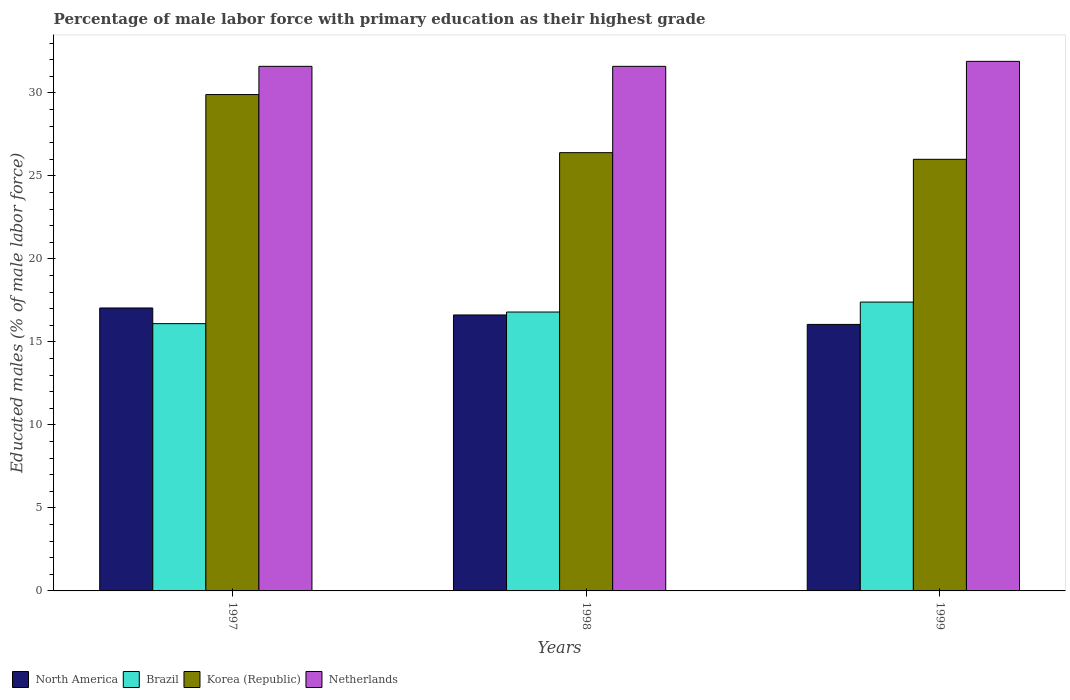How many different coloured bars are there?
Your answer should be compact. 4. How many groups of bars are there?
Provide a short and direct response. 3. Are the number of bars per tick equal to the number of legend labels?
Provide a short and direct response. Yes. What is the label of the 2nd group of bars from the left?
Give a very brief answer. 1998. What is the percentage of male labor force with primary education in Korea (Republic) in 1997?
Provide a short and direct response. 29.9. Across all years, what is the maximum percentage of male labor force with primary education in North America?
Keep it short and to the point. 17.04. Across all years, what is the minimum percentage of male labor force with primary education in North America?
Your response must be concise. 16.05. In which year was the percentage of male labor force with primary education in Netherlands minimum?
Ensure brevity in your answer.  1997. What is the total percentage of male labor force with primary education in Brazil in the graph?
Your response must be concise. 50.3. What is the difference between the percentage of male labor force with primary education in Korea (Republic) in 1998 and that in 1999?
Offer a very short reply. 0.4. What is the difference between the percentage of male labor force with primary education in North America in 1998 and the percentage of male labor force with primary education in Netherlands in 1999?
Your answer should be compact. -15.28. What is the average percentage of male labor force with primary education in Korea (Republic) per year?
Your response must be concise. 27.43. In the year 1997, what is the difference between the percentage of male labor force with primary education in Brazil and percentage of male labor force with primary education in Korea (Republic)?
Give a very brief answer. -13.8. In how many years, is the percentage of male labor force with primary education in Korea (Republic) greater than 21 %?
Your response must be concise. 3. What is the ratio of the percentage of male labor force with primary education in Brazil in 1997 to that in 1999?
Provide a short and direct response. 0.93. Is the percentage of male labor force with primary education in Brazil in 1997 less than that in 1998?
Offer a very short reply. Yes. Is the difference between the percentage of male labor force with primary education in Brazil in 1998 and 1999 greater than the difference between the percentage of male labor force with primary education in Korea (Republic) in 1998 and 1999?
Your answer should be very brief. No. What is the difference between the highest and the second highest percentage of male labor force with primary education in North America?
Your answer should be very brief. 0.42. What is the difference between the highest and the lowest percentage of male labor force with primary education in Brazil?
Offer a terse response. 1.3. In how many years, is the percentage of male labor force with primary education in North America greater than the average percentage of male labor force with primary education in North America taken over all years?
Give a very brief answer. 2. Is the sum of the percentage of male labor force with primary education in Korea (Republic) in 1998 and 1999 greater than the maximum percentage of male labor force with primary education in Netherlands across all years?
Ensure brevity in your answer.  Yes. What does the 2nd bar from the left in 1999 represents?
Your response must be concise. Brazil. What does the 1st bar from the right in 1997 represents?
Make the answer very short. Netherlands. Is it the case that in every year, the sum of the percentage of male labor force with primary education in Brazil and percentage of male labor force with primary education in North America is greater than the percentage of male labor force with primary education in Korea (Republic)?
Offer a terse response. Yes. What is the difference between two consecutive major ticks on the Y-axis?
Keep it short and to the point. 5. Does the graph contain grids?
Offer a terse response. No. How many legend labels are there?
Offer a very short reply. 4. How are the legend labels stacked?
Your answer should be compact. Horizontal. What is the title of the graph?
Your response must be concise. Percentage of male labor force with primary education as their highest grade. What is the label or title of the Y-axis?
Your response must be concise. Educated males (% of male labor force). What is the Educated males (% of male labor force) of North America in 1997?
Provide a short and direct response. 17.04. What is the Educated males (% of male labor force) of Brazil in 1997?
Your answer should be very brief. 16.1. What is the Educated males (% of male labor force) of Korea (Republic) in 1997?
Provide a short and direct response. 29.9. What is the Educated males (% of male labor force) in Netherlands in 1997?
Provide a succinct answer. 31.6. What is the Educated males (% of male labor force) in North America in 1998?
Ensure brevity in your answer.  16.62. What is the Educated males (% of male labor force) of Brazil in 1998?
Your answer should be compact. 16.8. What is the Educated males (% of male labor force) in Korea (Republic) in 1998?
Make the answer very short. 26.4. What is the Educated males (% of male labor force) of Netherlands in 1998?
Your answer should be very brief. 31.6. What is the Educated males (% of male labor force) in North America in 1999?
Offer a terse response. 16.05. What is the Educated males (% of male labor force) of Brazil in 1999?
Your answer should be compact. 17.4. What is the Educated males (% of male labor force) of Netherlands in 1999?
Your answer should be compact. 31.9. Across all years, what is the maximum Educated males (% of male labor force) in North America?
Give a very brief answer. 17.04. Across all years, what is the maximum Educated males (% of male labor force) in Brazil?
Keep it short and to the point. 17.4. Across all years, what is the maximum Educated males (% of male labor force) in Korea (Republic)?
Provide a succinct answer. 29.9. Across all years, what is the maximum Educated males (% of male labor force) in Netherlands?
Your answer should be very brief. 31.9. Across all years, what is the minimum Educated males (% of male labor force) of North America?
Give a very brief answer. 16.05. Across all years, what is the minimum Educated males (% of male labor force) in Brazil?
Keep it short and to the point. 16.1. Across all years, what is the minimum Educated males (% of male labor force) in Netherlands?
Give a very brief answer. 31.6. What is the total Educated males (% of male labor force) in North America in the graph?
Your response must be concise. 49.72. What is the total Educated males (% of male labor force) in Brazil in the graph?
Provide a succinct answer. 50.3. What is the total Educated males (% of male labor force) in Korea (Republic) in the graph?
Ensure brevity in your answer.  82.3. What is the total Educated males (% of male labor force) in Netherlands in the graph?
Your response must be concise. 95.1. What is the difference between the Educated males (% of male labor force) in North America in 1997 and that in 1998?
Provide a succinct answer. 0.42. What is the difference between the Educated males (% of male labor force) in Korea (Republic) in 1997 and that in 1998?
Your response must be concise. 3.5. What is the difference between the Educated males (% of male labor force) in Netherlands in 1997 and that in 1998?
Provide a succinct answer. 0. What is the difference between the Educated males (% of male labor force) of North America in 1997 and that in 1999?
Offer a terse response. 0.99. What is the difference between the Educated males (% of male labor force) of Brazil in 1997 and that in 1999?
Provide a short and direct response. -1.3. What is the difference between the Educated males (% of male labor force) of North America in 1998 and that in 1999?
Provide a short and direct response. 0.57. What is the difference between the Educated males (% of male labor force) in Korea (Republic) in 1998 and that in 1999?
Your response must be concise. 0.4. What is the difference between the Educated males (% of male labor force) in North America in 1997 and the Educated males (% of male labor force) in Brazil in 1998?
Offer a terse response. 0.24. What is the difference between the Educated males (% of male labor force) of North America in 1997 and the Educated males (% of male labor force) of Korea (Republic) in 1998?
Your answer should be very brief. -9.36. What is the difference between the Educated males (% of male labor force) in North America in 1997 and the Educated males (% of male labor force) in Netherlands in 1998?
Your answer should be compact. -14.56. What is the difference between the Educated males (% of male labor force) of Brazil in 1997 and the Educated males (% of male labor force) of Netherlands in 1998?
Make the answer very short. -15.5. What is the difference between the Educated males (% of male labor force) in Korea (Republic) in 1997 and the Educated males (% of male labor force) in Netherlands in 1998?
Make the answer very short. -1.7. What is the difference between the Educated males (% of male labor force) of North America in 1997 and the Educated males (% of male labor force) of Brazil in 1999?
Your answer should be compact. -0.36. What is the difference between the Educated males (% of male labor force) of North America in 1997 and the Educated males (% of male labor force) of Korea (Republic) in 1999?
Your response must be concise. -8.96. What is the difference between the Educated males (% of male labor force) of North America in 1997 and the Educated males (% of male labor force) of Netherlands in 1999?
Your answer should be very brief. -14.86. What is the difference between the Educated males (% of male labor force) in Brazil in 1997 and the Educated males (% of male labor force) in Korea (Republic) in 1999?
Give a very brief answer. -9.9. What is the difference between the Educated males (% of male labor force) of Brazil in 1997 and the Educated males (% of male labor force) of Netherlands in 1999?
Make the answer very short. -15.8. What is the difference between the Educated males (% of male labor force) in Korea (Republic) in 1997 and the Educated males (% of male labor force) in Netherlands in 1999?
Provide a short and direct response. -2. What is the difference between the Educated males (% of male labor force) in North America in 1998 and the Educated males (% of male labor force) in Brazil in 1999?
Provide a succinct answer. -0.78. What is the difference between the Educated males (% of male labor force) in North America in 1998 and the Educated males (% of male labor force) in Korea (Republic) in 1999?
Offer a terse response. -9.38. What is the difference between the Educated males (% of male labor force) in North America in 1998 and the Educated males (% of male labor force) in Netherlands in 1999?
Provide a succinct answer. -15.28. What is the difference between the Educated males (% of male labor force) in Brazil in 1998 and the Educated males (% of male labor force) in Netherlands in 1999?
Your response must be concise. -15.1. What is the difference between the Educated males (% of male labor force) of Korea (Republic) in 1998 and the Educated males (% of male labor force) of Netherlands in 1999?
Offer a terse response. -5.5. What is the average Educated males (% of male labor force) in North America per year?
Your response must be concise. 16.57. What is the average Educated males (% of male labor force) in Brazil per year?
Offer a terse response. 16.77. What is the average Educated males (% of male labor force) in Korea (Republic) per year?
Ensure brevity in your answer.  27.43. What is the average Educated males (% of male labor force) of Netherlands per year?
Provide a short and direct response. 31.7. In the year 1997, what is the difference between the Educated males (% of male labor force) of North America and Educated males (% of male labor force) of Brazil?
Offer a very short reply. 0.94. In the year 1997, what is the difference between the Educated males (% of male labor force) in North America and Educated males (% of male labor force) in Korea (Republic)?
Provide a succinct answer. -12.86. In the year 1997, what is the difference between the Educated males (% of male labor force) in North America and Educated males (% of male labor force) in Netherlands?
Ensure brevity in your answer.  -14.56. In the year 1997, what is the difference between the Educated males (% of male labor force) of Brazil and Educated males (% of male labor force) of Korea (Republic)?
Your response must be concise. -13.8. In the year 1997, what is the difference between the Educated males (% of male labor force) in Brazil and Educated males (% of male labor force) in Netherlands?
Your answer should be very brief. -15.5. In the year 1998, what is the difference between the Educated males (% of male labor force) in North America and Educated males (% of male labor force) in Brazil?
Your answer should be very brief. -0.18. In the year 1998, what is the difference between the Educated males (% of male labor force) of North America and Educated males (% of male labor force) of Korea (Republic)?
Your answer should be very brief. -9.78. In the year 1998, what is the difference between the Educated males (% of male labor force) in North America and Educated males (% of male labor force) in Netherlands?
Give a very brief answer. -14.98. In the year 1998, what is the difference between the Educated males (% of male labor force) of Brazil and Educated males (% of male labor force) of Korea (Republic)?
Provide a short and direct response. -9.6. In the year 1998, what is the difference between the Educated males (% of male labor force) in Brazil and Educated males (% of male labor force) in Netherlands?
Your answer should be very brief. -14.8. In the year 1999, what is the difference between the Educated males (% of male labor force) in North America and Educated males (% of male labor force) in Brazil?
Provide a short and direct response. -1.35. In the year 1999, what is the difference between the Educated males (% of male labor force) in North America and Educated males (% of male labor force) in Korea (Republic)?
Your answer should be compact. -9.95. In the year 1999, what is the difference between the Educated males (% of male labor force) in North America and Educated males (% of male labor force) in Netherlands?
Your response must be concise. -15.85. In the year 1999, what is the difference between the Educated males (% of male labor force) of Brazil and Educated males (% of male labor force) of Netherlands?
Make the answer very short. -14.5. What is the ratio of the Educated males (% of male labor force) in North America in 1997 to that in 1998?
Provide a succinct answer. 1.03. What is the ratio of the Educated males (% of male labor force) of Korea (Republic) in 1997 to that in 1998?
Provide a short and direct response. 1.13. What is the ratio of the Educated males (% of male labor force) in Netherlands in 1997 to that in 1998?
Your response must be concise. 1. What is the ratio of the Educated males (% of male labor force) in North America in 1997 to that in 1999?
Ensure brevity in your answer.  1.06. What is the ratio of the Educated males (% of male labor force) in Brazil in 1997 to that in 1999?
Your answer should be compact. 0.93. What is the ratio of the Educated males (% of male labor force) of Korea (Republic) in 1997 to that in 1999?
Your answer should be compact. 1.15. What is the ratio of the Educated males (% of male labor force) of Netherlands in 1997 to that in 1999?
Your answer should be very brief. 0.99. What is the ratio of the Educated males (% of male labor force) in North America in 1998 to that in 1999?
Make the answer very short. 1.04. What is the ratio of the Educated males (% of male labor force) in Brazil in 1998 to that in 1999?
Give a very brief answer. 0.97. What is the ratio of the Educated males (% of male labor force) in Korea (Republic) in 1998 to that in 1999?
Make the answer very short. 1.02. What is the ratio of the Educated males (% of male labor force) in Netherlands in 1998 to that in 1999?
Your answer should be compact. 0.99. What is the difference between the highest and the second highest Educated males (% of male labor force) in North America?
Your answer should be compact. 0.42. What is the difference between the highest and the lowest Educated males (% of male labor force) of Korea (Republic)?
Offer a very short reply. 3.9. What is the difference between the highest and the lowest Educated males (% of male labor force) of Netherlands?
Make the answer very short. 0.3. 